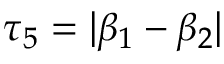<formula> <loc_0><loc_0><loc_500><loc_500>\tau _ { 5 } = | \beta _ { 1 } - \beta _ { 2 } |</formula> 